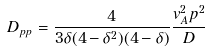<formula> <loc_0><loc_0><loc_500><loc_500>D _ { p p } = \frac { 4 } { 3 \delta ( 4 - \delta ^ { 2 } ) ( 4 - \delta ) } \frac { v _ { A } ^ { 2 } p ^ { 2 } } { D }</formula> 